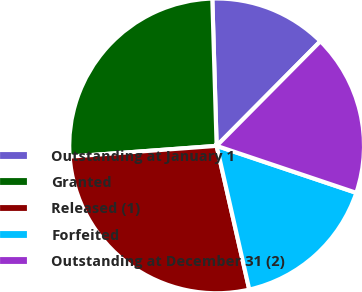Convert chart. <chart><loc_0><loc_0><loc_500><loc_500><pie_chart><fcel>Outstanding at January 1<fcel>Granted<fcel>Released (1)<fcel>Forfeited<fcel>Outstanding at December 31 (2)<nl><fcel>12.9%<fcel>25.7%<fcel>27.39%<fcel>16.28%<fcel>17.73%<nl></chart> 